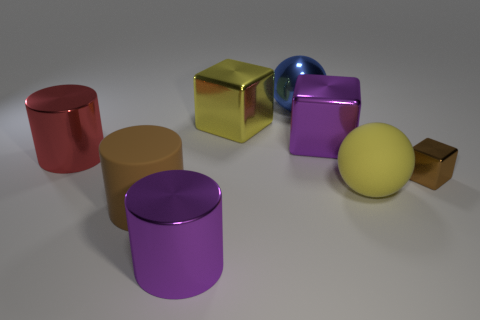Add 1 blue metallic balls. How many objects exist? 9 Subtract all cubes. How many objects are left? 5 Subtract all big brown things. Subtract all large cylinders. How many objects are left? 4 Add 3 brown cubes. How many brown cubes are left? 4 Add 3 big metal objects. How many big metal objects exist? 8 Subtract 0 blue cylinders. How many objects are left? 8 